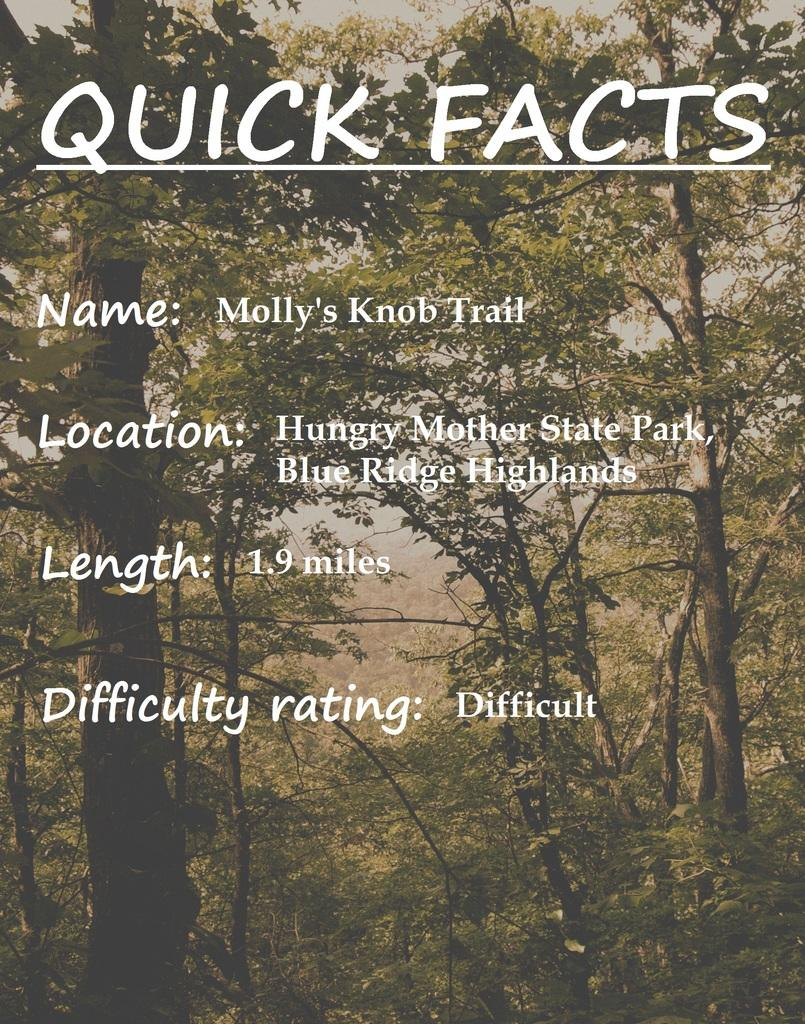<image>
Provide a brief description of the given image. A picture of a washed out forest with white text describing different quick facts. 